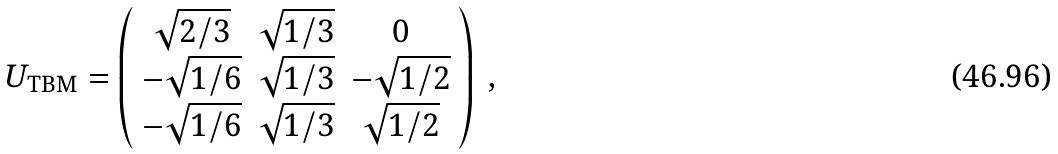<formula> <loc_0><loc_0><loc_500><loc_500>U _ { \text {TBM} } = \left ( \begin{array} { c c c } \sqrt { 2 / 3 } & \sqrt { 1 / 3 } & 0 \\ - \sqrt { 1 / 6 } & \sqrt { 1 / 3 } & - \sqrt { 1 / 2 } \\ - \sqrt { 1 / 6 } & \sqrt { 1 / 3 } & \sqrt { 1 / 2 } \\ \end{array} \right ) \ ,</formula> 